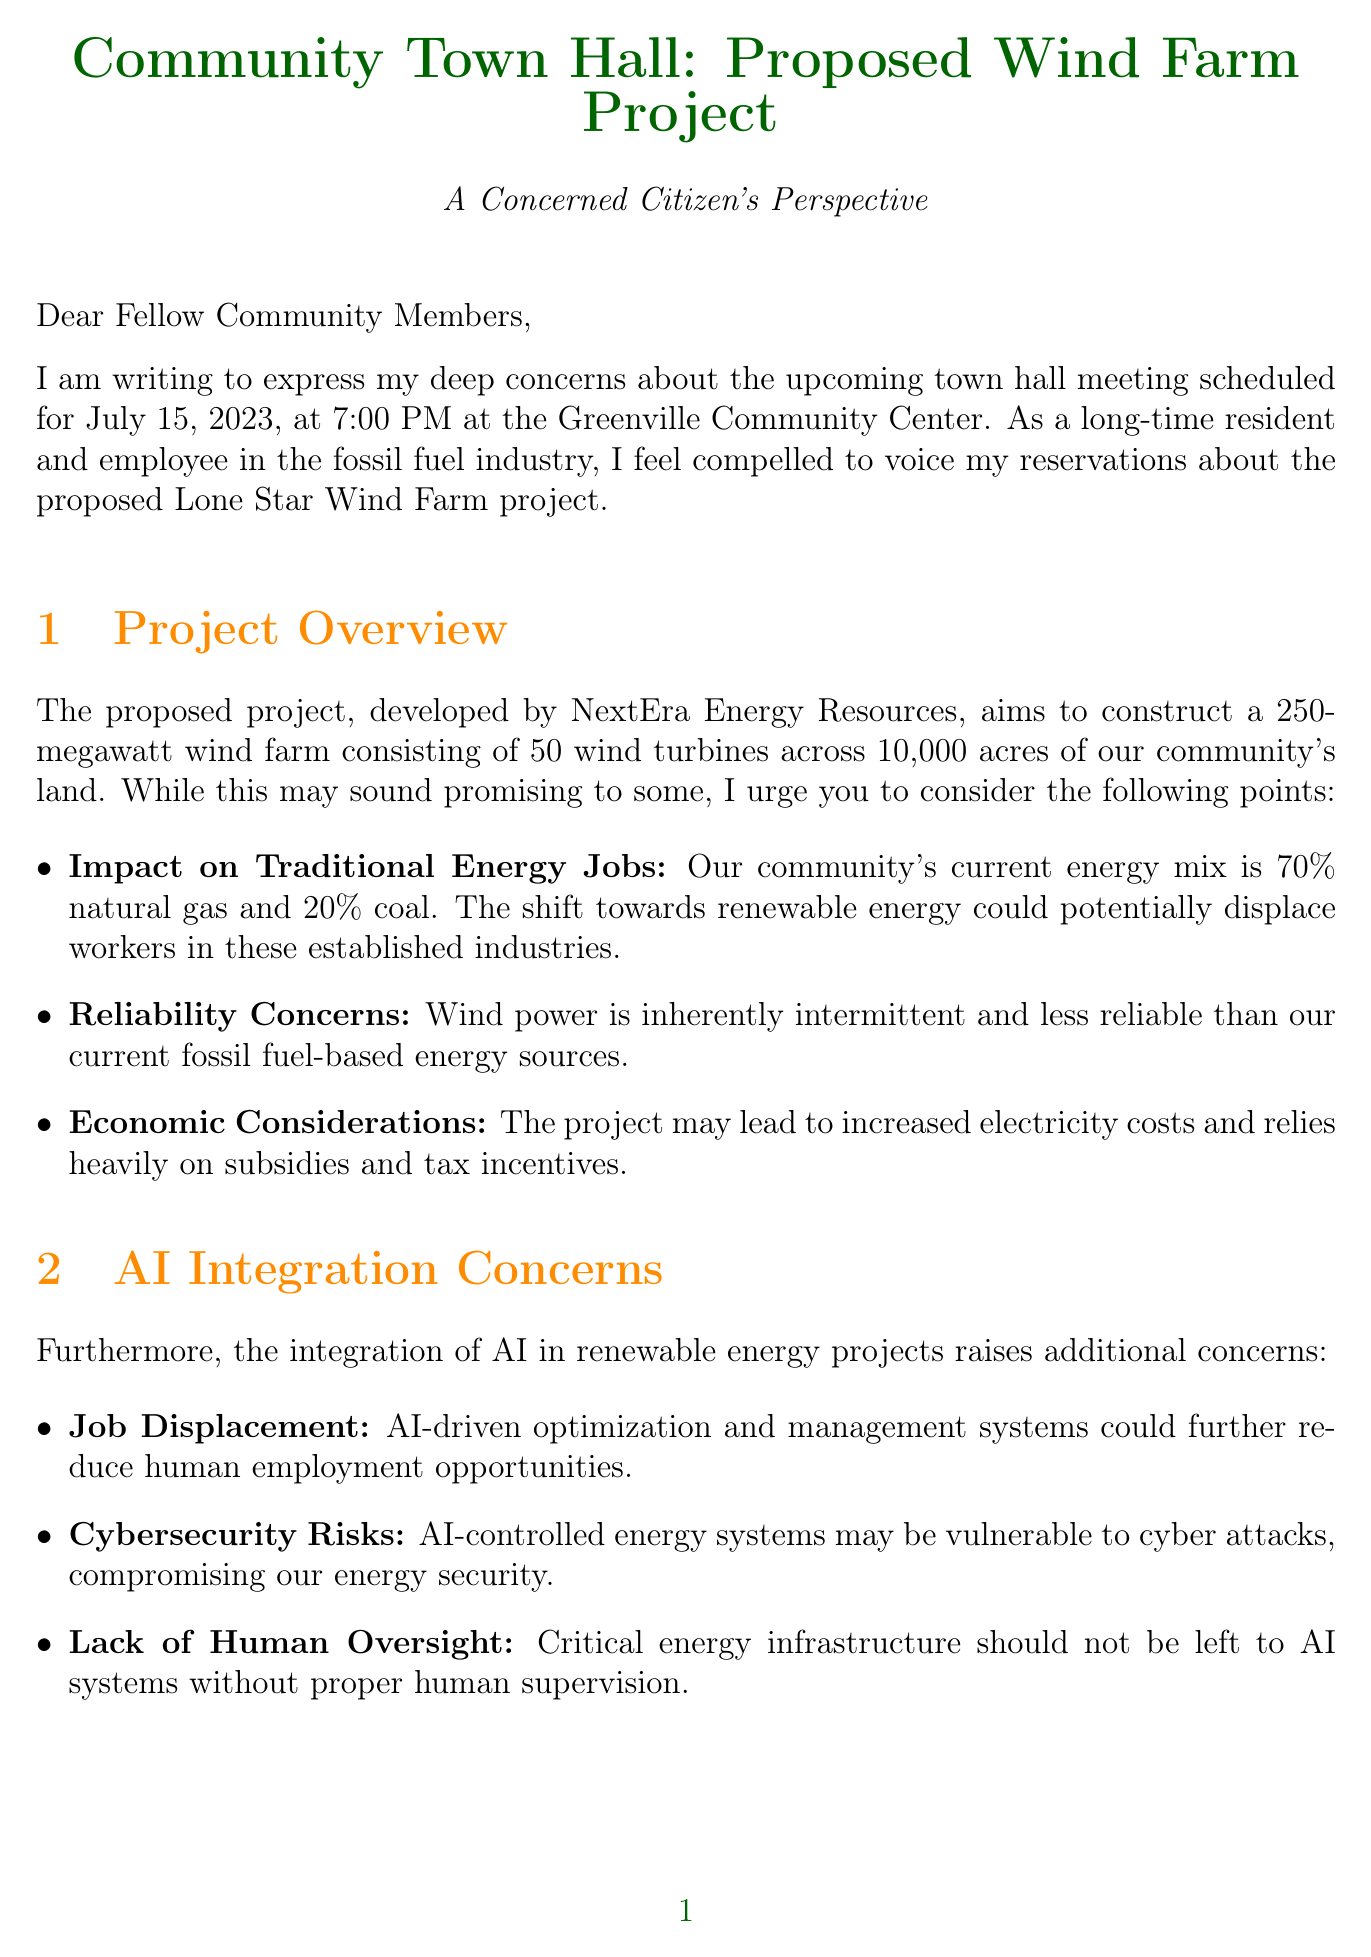What is the date of the town hall meeting? The date of the town hall meeting is specified in the document as July 15, 2023.
Answer: July 15, 2023 Who is the developer of the Lone Star Wind Farm? The document states that the developer of the Lone Star Wind Farm is NextEra Energy Resources.
Answer: NextEra Energy Resources What is the capacity of the proposed wind farm? The capacity of the proposed wind farm is mentioned in the document as 250 megawatts.
Answer: 250 megawatts What percentage of the current energy mix is renewable? The current energy mix has 10% renewable energy according to the document.
Answer: 10% What is a potential concern regarding the job market? The document lists "Impact on traditional energy sector jobs" as a potential concern related to the wind farm project.
Answer: Impact on traditional energy sector jobs How many wind turbines are planned for the project? The number of wind turbines planned for the project is detailed in the document as 50.
Answer: 50 wind turbines What question is included in the agenda items? One of the agenda items is "Impact on local wildlife and migratory birds," which is mentioned in the document.
Answer: Impact on local wildlife and migratory birds Who is the Project Manager for NextEra Energy Resources? The document identifies Sarah Johnson as the Project Manager for NextEra Energy Resources.
Answer: Sarah Johnson What is one of the potential cybersecurity risks mentioned? The document states that "Cybersecurity risks associated with AI-controlled energy systems" is a potential cybersecurity risk.
Answer: Cybersecurity risks associated with AI-controlled energy systems 